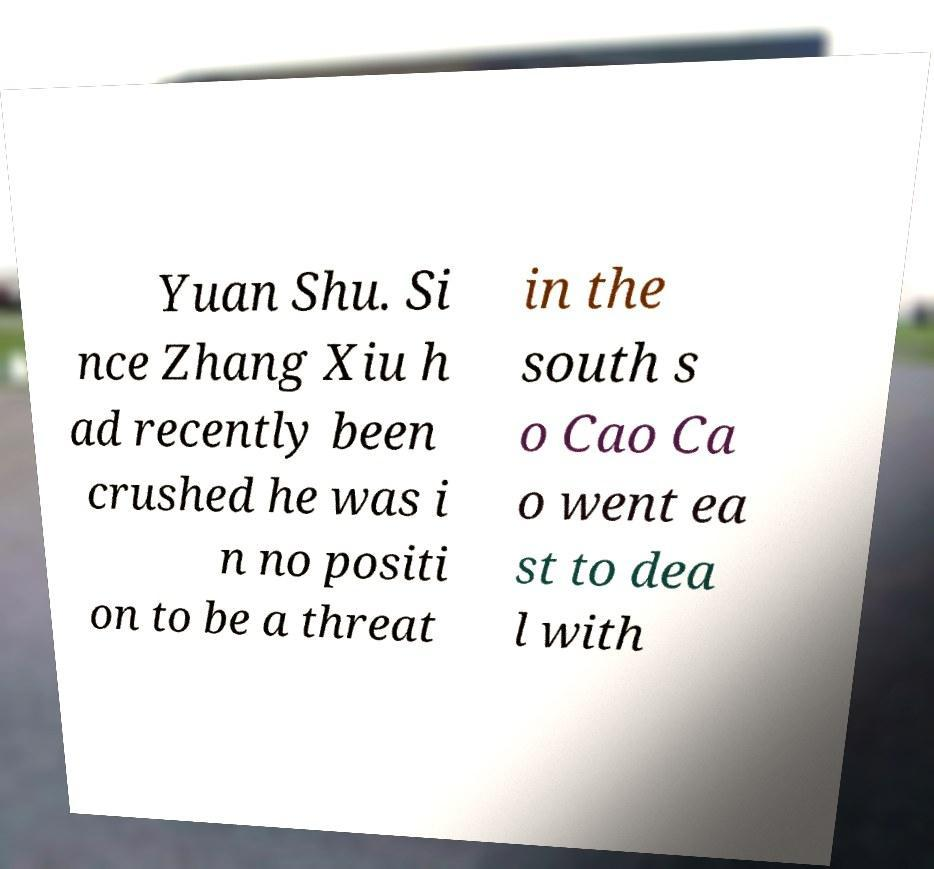There's text embedded in this image that I need extracted. Can you transcribe it verbatim? Yuan Shu. Si nce Zhang Xiu h ad recently been crushed he was i n no positi on to be a threat in the south s o Cao Ca o went ea st to dea l with 